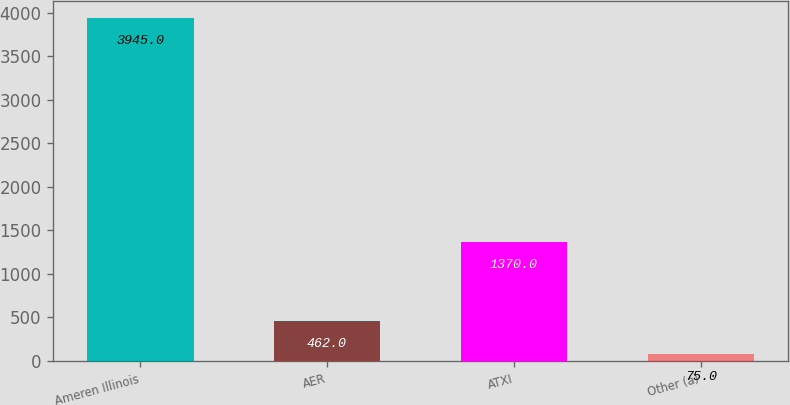Convert chart. <chart><loc_0><loc_0><loc_500><loc_500><bar_chart><fcel>Ameren Illinois<fcel>AER<fcel>ATXI<fcel>Other (a)<nl><fcel>3945<fcel>462<fcel>1370<fcel>75<nl></chart> 